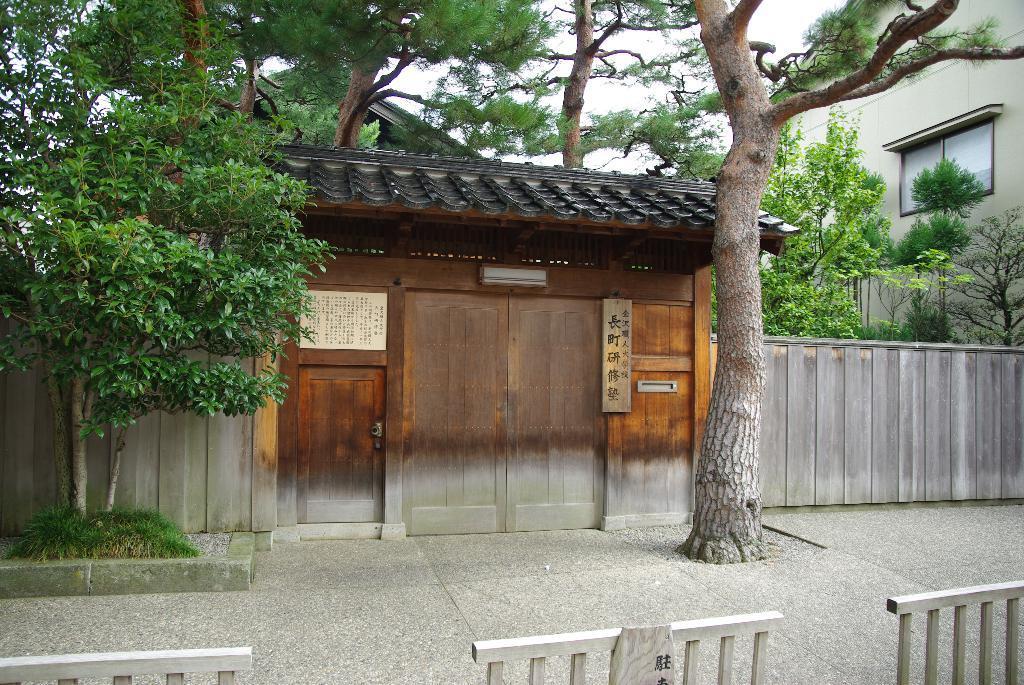Describe this image in one or two sentences. In the picture I can see their barrier gates, wooden house, trees, fence, another building on the right side of the image and the sky in the background. 